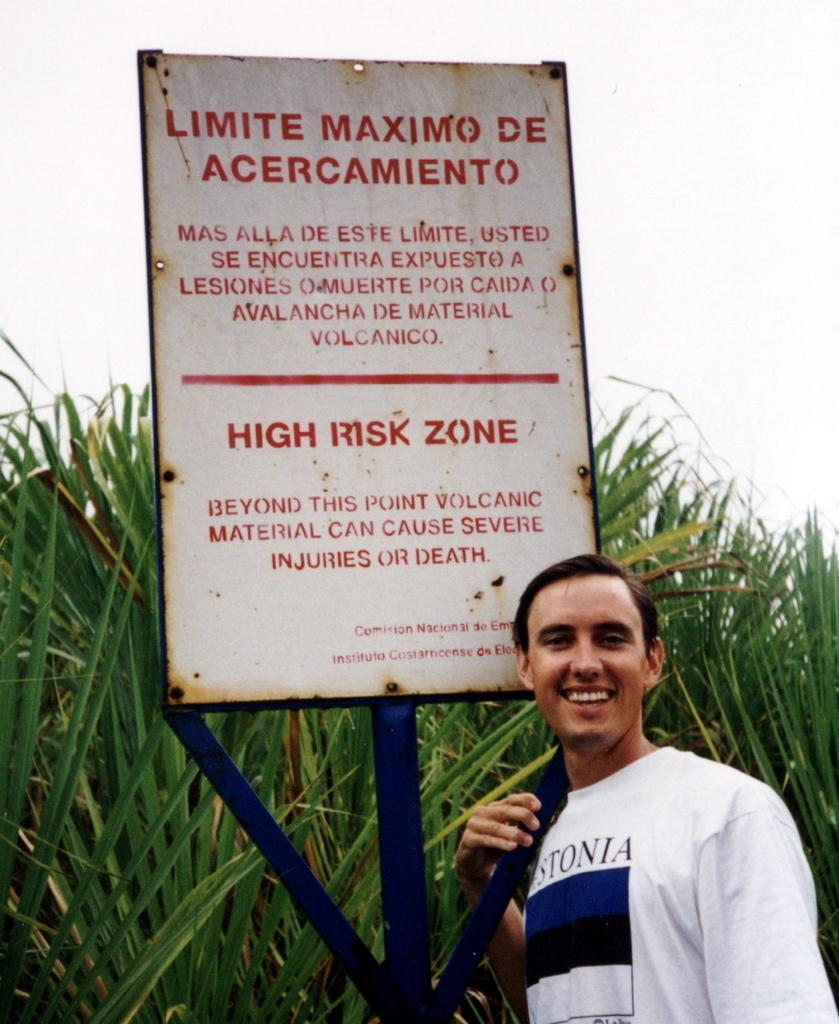<image>
Share a concise interpretation of the image provided. the man is standing next a sign saying high risk zone 